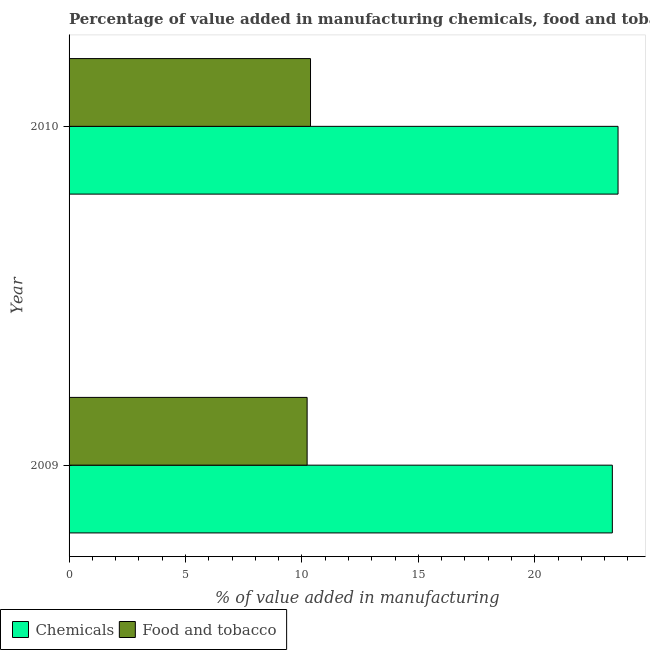How many groups of bars are there?
Your answer should be very brief. 2. Are the number of bars per tick equal to the number of legend labels?
Your answer should be very brief. Yes. What is the label of the 2nd group of bars from the top?
Keep it short and to the point. 2009. In how many cases, is the number of bars for a given year not equal to the number of legend labels?
Your answer should be compact. 0. What is the value added by  manufacturing chemicals in 2010?
Keep it short and to the point. 23.57. Across all years, what is the maximum value added by  manufacturing chemicals?
Your response must be concise. 23.57. Across all years, what is the minimum value added by manufacturing food and tobacco?
Provide a short and direct response. 10.22. In which year was the value added by manufacturing food and tobacco maximum?
Offer a terse response. 2010. What is the total value added by  manufacturing chemicals in the graph?
Make the answer very short. 46.9. What is the difference between the value added by  manufacturing chemicals in 2009 and that in 2010?
Make the answer very short. -0.24. What is the difference between the value added by  manufacturing chemicals in 2009 and the value added by manufacturing food and tobacco in 2010?
Ensure brevity in your answer.  12.96. What is the average value added by manufacturing food and tobacco per year?
Provide a short and direct response. 10.29. In the year 2010, what is the difference between the value added by manufacturing food and tobacco and value added by  manufacturing chemicals?
Make the answer very short. -13.21. In how many years, is the value added by  manufacturing chemicals greater than 13 %?
Give a very brief answer. 2. Is the value added by  manufacturing chemicals in 2009 less than that in 2010?
Your response must be concise. Yes. In how many years, is the value added by manufacturing food and tobacco greater than the average value added by manufacturing food and tobacco taken over all years?
Your response must be concise. 1. What does the 1st bar from the top in 2010 represents?
Provide a short and direct response. Food and tobacco. What does the 1st bar from the bottom in 2010 represents?
Ensure brevity in your answer.  Chemicals. Are all the bars in the graph horizontal?
Provide a short and direct response. Yes. What is the difference between two consecutive major ticks on the X-axis?
Offer a terse response. 5. What is the title of the graph?
Provide a short and direct response. Percentage of value added in manufacturing chemicals, food and tobacco in Switzerland. What is the label or title of the X-axis?
Offer a very short reply. % of value added in manufacturing. What is the % of value added in manufacturing of Chemicals in 2009?
Ensure brevity in your answer.  23.33. What is the % of value added in manufacturing in Food and tobacco in 2009?
Your response must be concise. 10.22. What is the % of value added in manufacturing of Chemicals in 2010?
Give a very brief answer. 23.57. What is the % of value added in manufacturing in Food and tobacco in 2010?
Offer a very short reply. 10.37. Across all years, what is the maximum % of value added in manufacturing in Chemicals?
Keep it short and to the point. 23.57. Across all years, what is the maximum % of value added in manufacturing in Food and tobacco?
Your response must be concise. 10.37. Across all years, what is the minimum % of value added in manufacturing of Chemicals?
Offer a terse response. 23.33. Across all years, what is the minimum % of value added in manufacturing of Food and tobacco?
Make the answer very short. 10.22. What is the total % of value added in manufacturing of Chemicals in the graph?
Offer a terse response. 46.9. What is the total % of value added in manufacturing of Food and tobacco in the graph?
Your answer should be compact. 20.59. What is the difference between the % of value added in manufacturing of Chemicals in 2009 and that in 2010?
Ensure brevity in your answer.  -0.24. What is the difference between the % of value added in manufacturing in Food and tobacco in 2009 and that in 2010?
Provide a succinct answer. -0.14. What is the difference between the % of value added in manufacturing in Chemicals in 2009 and the % of value added in manufacturing in Food and tobacco in 2010?
Offer a terse response. 12.96. What is the average % of value added in manufacturing of Chemicals per year?
Provide a short and direct response. 23.45. What is the average % of value added in manufacturing in Food and tobacco per year?
Keep it short and to the point. 10.3. In the year 2009, what is the difference between the % of value added in manufacturing of Chemicals and % of value added in manufacturing of Food and tobacco?
Give a very brief answer. 13.11. In the year 2010, what is the difference between the % of value added in manufacturing of Chemicals and % of value added in manufacturing of Food and tobacco?
Provide a short and direct response. 13.21. What is the ratio of the % of value added in manufacturing of Chemicals in 2009 to that in 2010?
Offer a terse response. 0.99. What is the ratio of the % of value added in manufacturing in Food and tobacco in 2009 to that in 2010?
Provide a succinct answer. 0.99. What is the difference between the highest and the second highest % of value added in manufacturing of Chemicals?
Ensure brevity in your answer.  0.24. What is the difference between the highest and the second highest % of value added in manufacturing of Food and tobacco?
Keep it short and to the point. 0.14. What is the difference between the highest and the lowest % of value added in manufacturing of Chemicals?
Provide a succinct answer. 0.24. What is the difference between the highest and the lowest % of value added in manufacturing of Food and tobacco?
Make the answer very short. 0.14. 